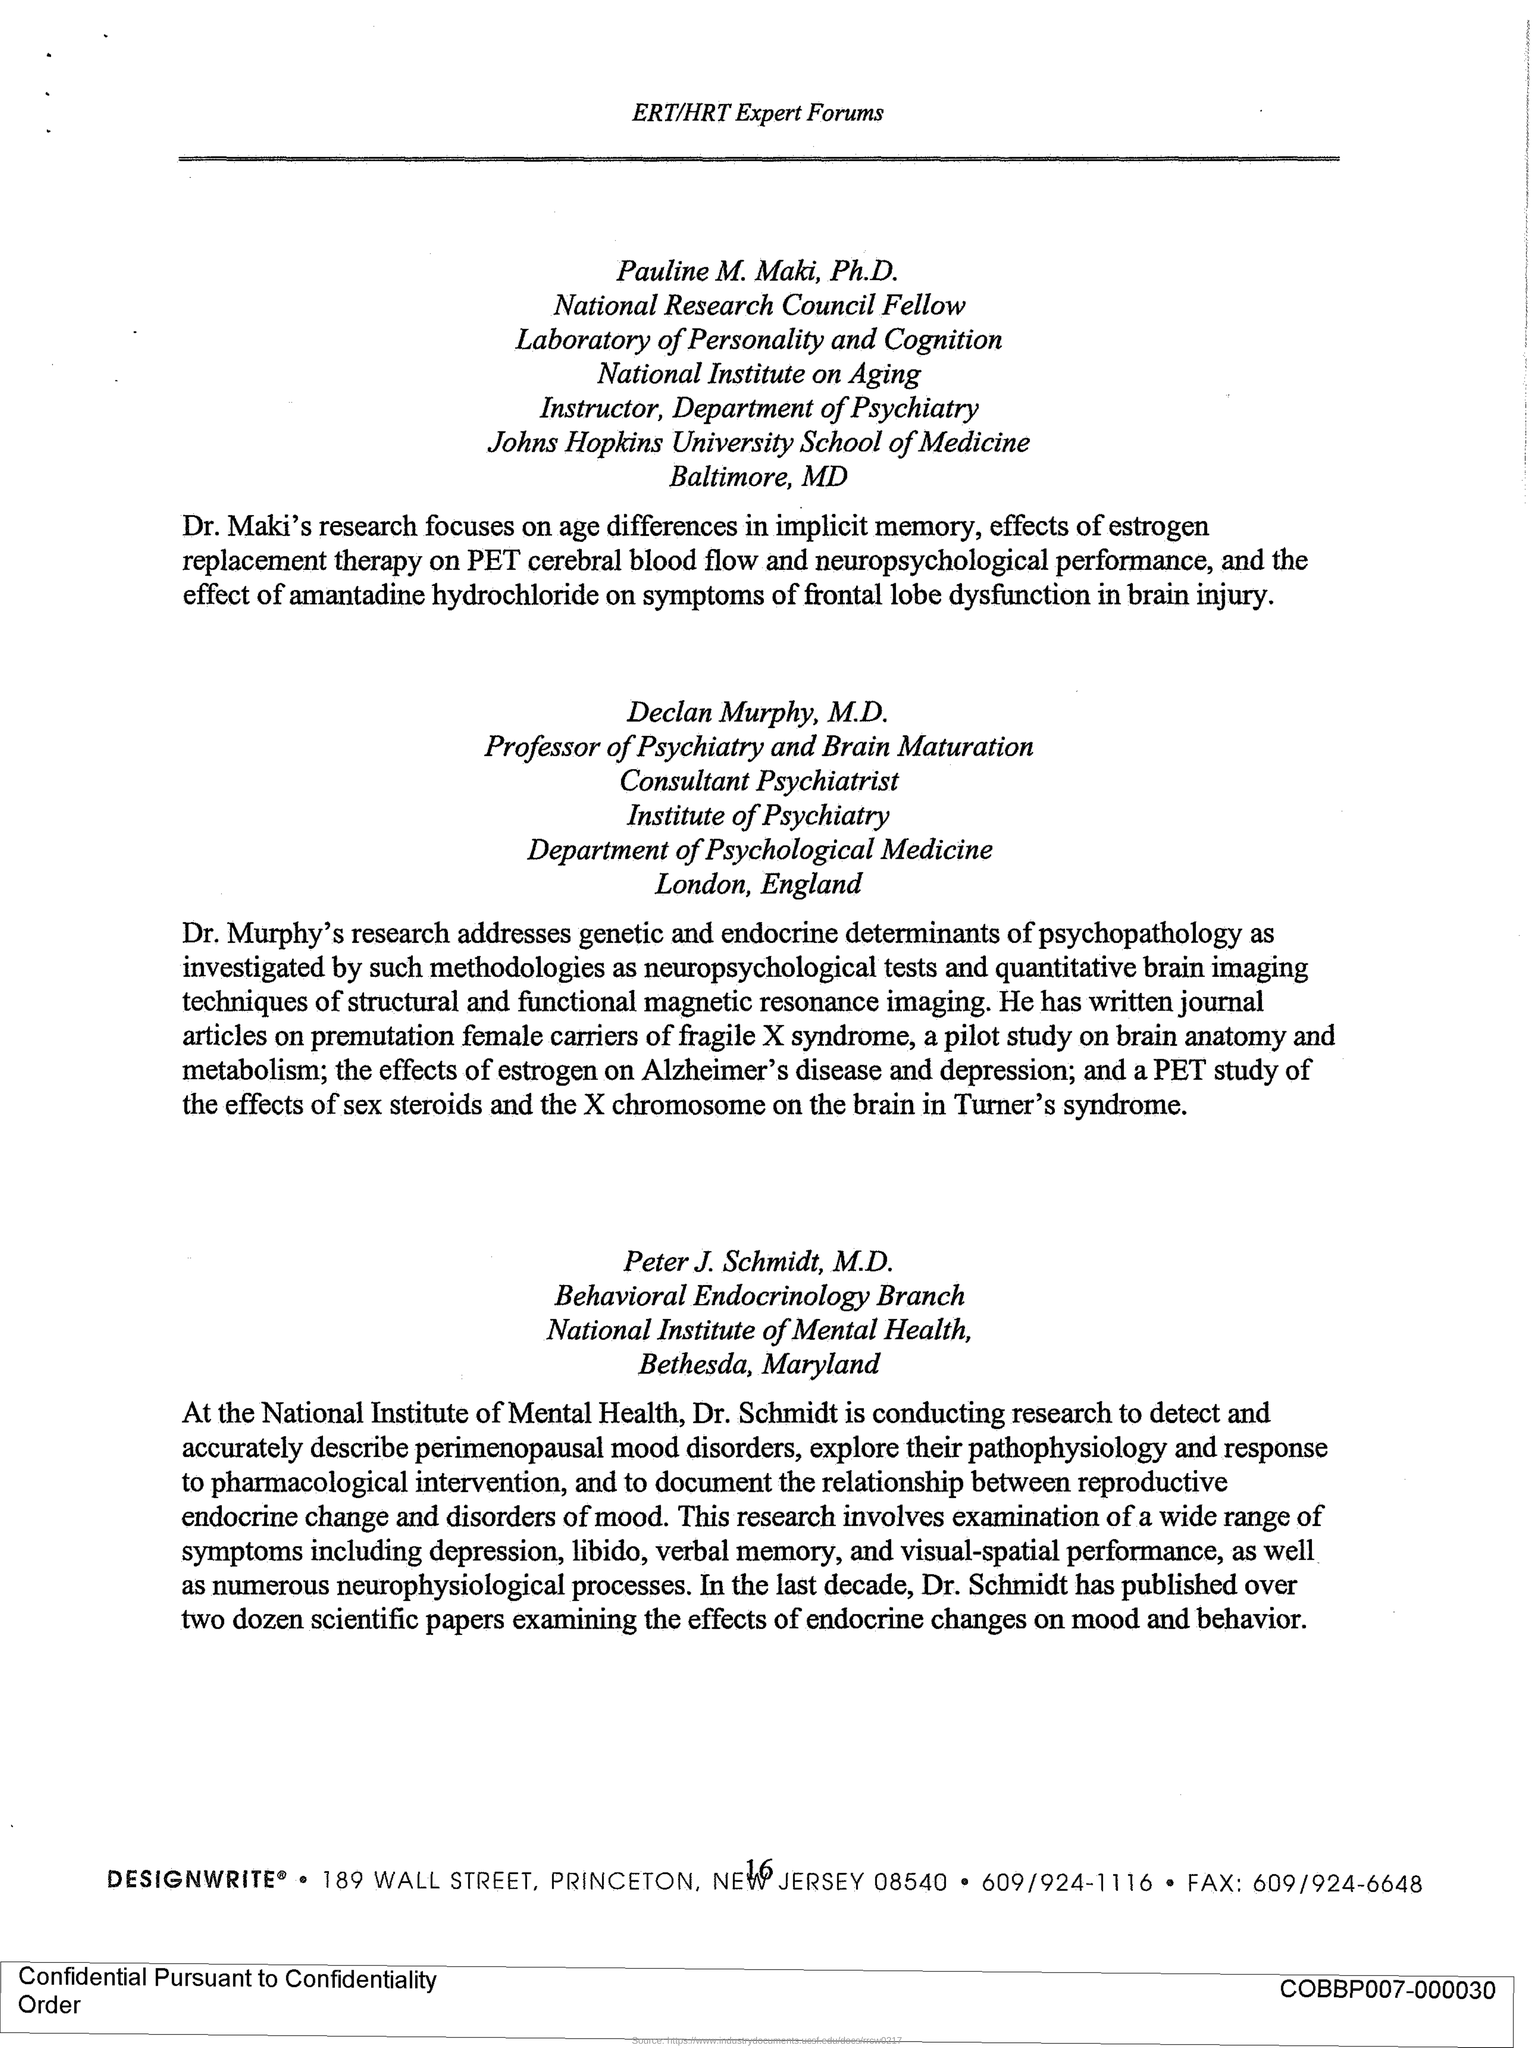What is Pauline's designation?
Your response must be concise. National Research Council Fellow. Who is the Professor of Psychiatry and Brain Maturation?
Your answer should be very brief. Declan Murphy, M.D. Which branch is Peter J. Schmidt, M.D. part of?
Keep it short and to the point. Behavioral Endocrinology Branch. 